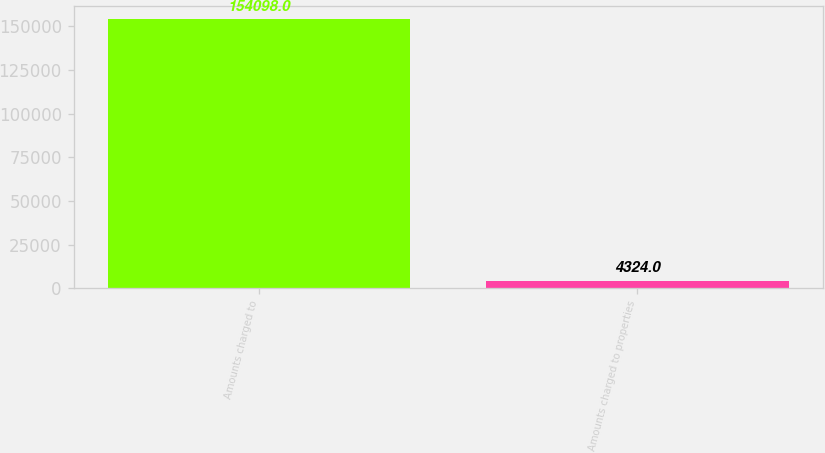<chart> <loc_0><loc_0><loc_500><loc_500><bar_chart><fcel>Amounts charged to<fcel>Amounts charged to properties<nl><fcel>154098<fcel>4324<nl></chart> 